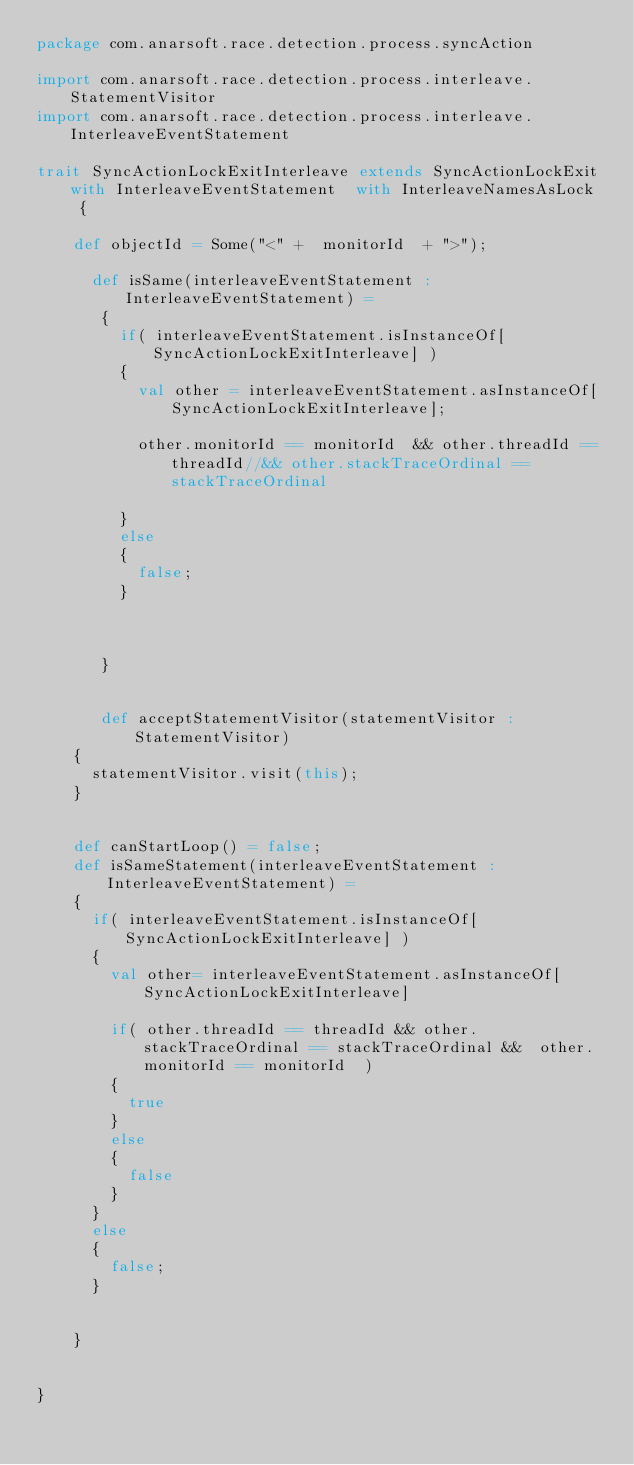Convert code to text. <code><loc_0><loc_0><loc_500><loc_500><_Scala_>package com.anarsoft.race.detection.process.syncAction

import com.anarsoft.race.detection.process.interleave.StatementVisitor
import com.anarsoft.race.detection.process.interleave.InterleaveEventStatement

trait SyncActionLockExitInterleave extends SyncActionLockExit with InterleaveEventStatement  with InterleaveNamesAsLock  {
       
    def objectId = Some("<" +  monitorId  + ">");   
     
      def isSame(interleaveEventStatement :  InterleaveEventStatement) =
       {
         if( interleaveEventStatement.isInstanceOf[SyncActionLockExitInterleave] )
         {
           val other = interleaveEventStatement.asInstanceOf[SyncActionLockExitInterleave];
           
           other.monitorId == monitorId  && other.threadId == threadId//&& other.stackTraceOrdinal == stackTraceOrdinal
           
         }
         else
         {
           false;
         }
         
         
         
       }
      
      
       def acceptStatementVisitor(statementVisitor : StatementVisitor)    
    {
      statementVisitor.visit(this);
    }
       
       
    def canStartLoop() = false;
    def isSameStatement(interleaveEventStatement :  InterleaveEventStatement) =
    {
      if( interleaveEventStatement.isInstanceOf[SyncActionLockExitInterleave] )
      {
        val other= interleaveEventStatement.asInstanceOf[SyncActionLockExitInterleave] 
        
        if( other.threadId == threadId && other.stackTraceOrdinal == stackTraceOrdinal &&  other.monitorId == monitorId  )
        {
          true
        }
        else
        {
          false
        }
      }
      else
      {
        false;
      }
      
      
    }     
         
     
}</code> 